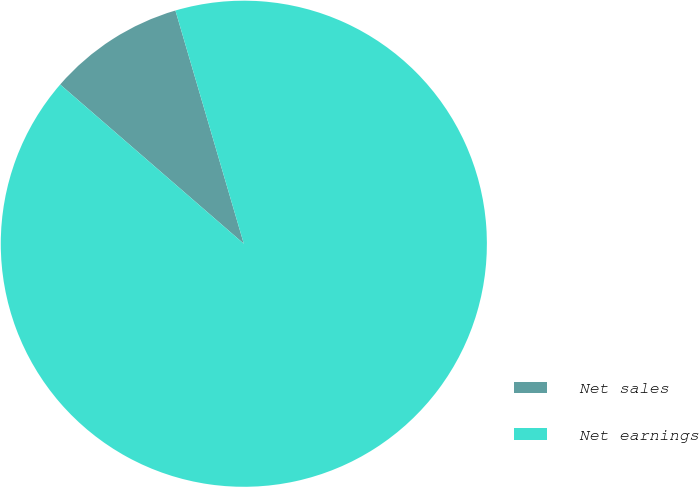Convert chart. <chart><loc_0><loc_0><loc_500><loc_500><pie_chart><fcel>Net sales<fcel>Net earnings<nl><fcel>9.09%<fcel>90.91%<nl></chart> 